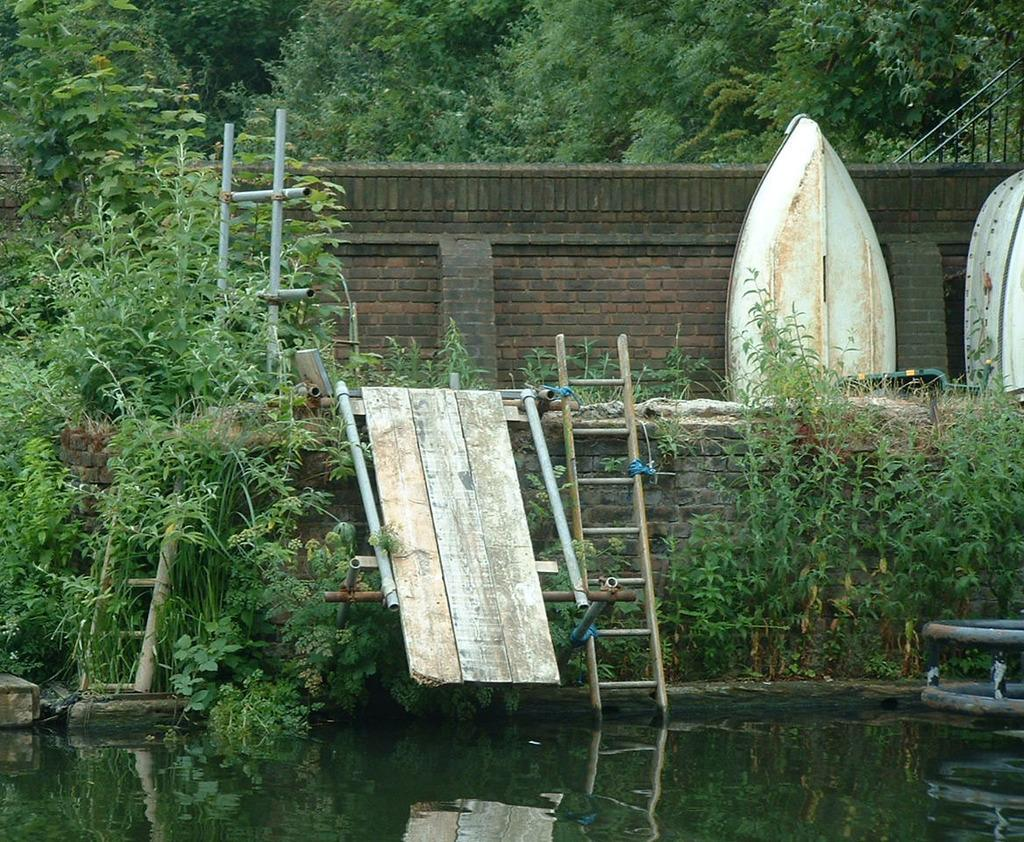What is the primary element in the image? The image contains water. What type of living organisms can be seen in the image? Plants are visible in the image. What objects are present in the image that might be used for climbing or reaching higher places? There are ladders in the image. What can be seen in the background of the image? There is a wall and trees in the background of the image. What type of plate is being used to serve the food in the image? There is no plate or food present in the image; it contains water, plants, ladders, a wall, and trees. Can you see a mitten being used to protect someone's hands in the image? There is no mitten present in the image. 